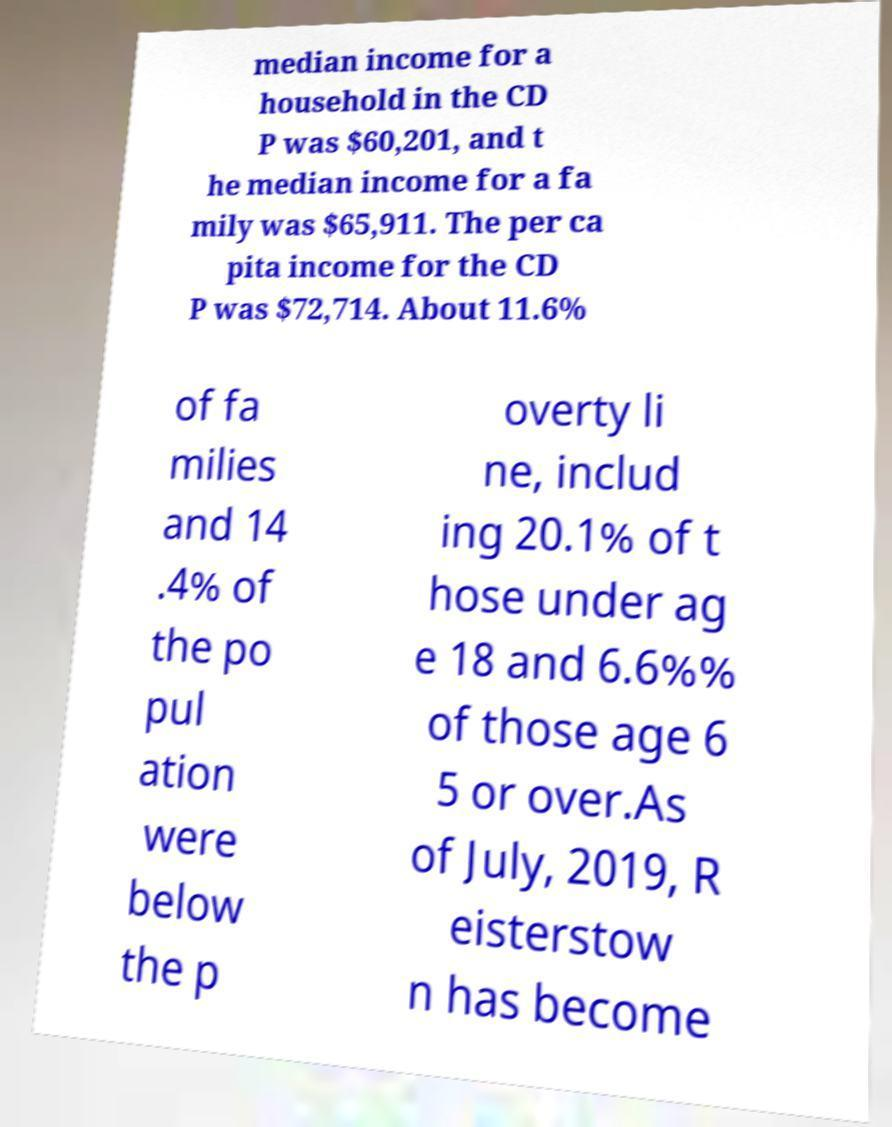Could you extract and type out the text from this image? median income for a household in the CD P was $60,201, and t he median income for a fa mily was $65,911. The per ca pita income for the CD P was $72,714. About 11.6% of fa milies and 14 .4% of the po pul ation were below the p overty li ne, includ ing 20.1% of t hose under ag e 18 and 6.6%% of those age 6 5 or over.As of July, 2019, R eisterstow n has become 